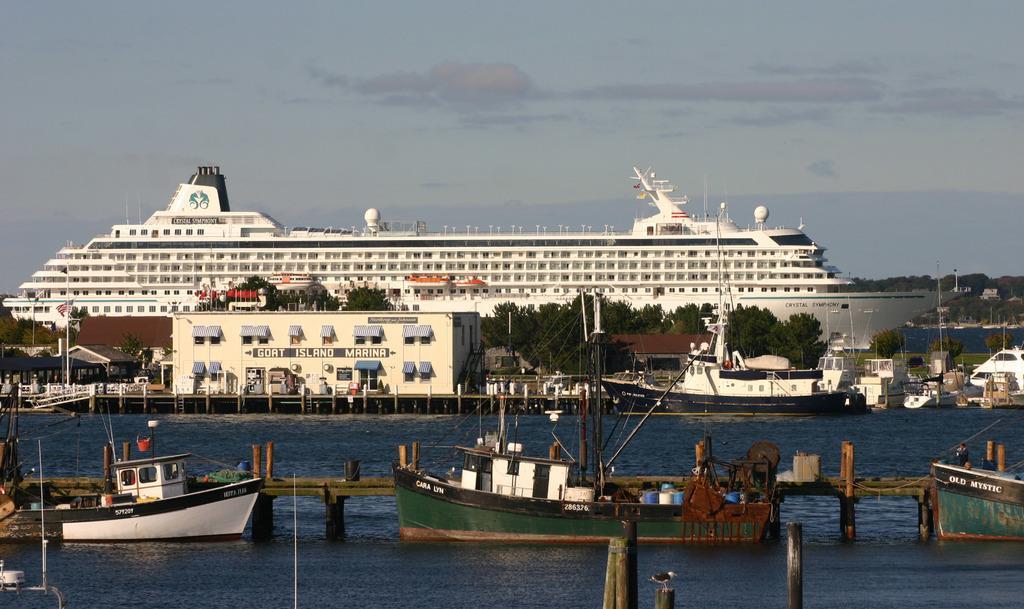How would you summarize this image in a sentence or two? In this image there are boats in water. There is a wooden fencing. In the background of the image there is a white color ship. There is a house with windows. There are poles, trees. To the right side of the image there are ships. At the top of the image there is sky. 